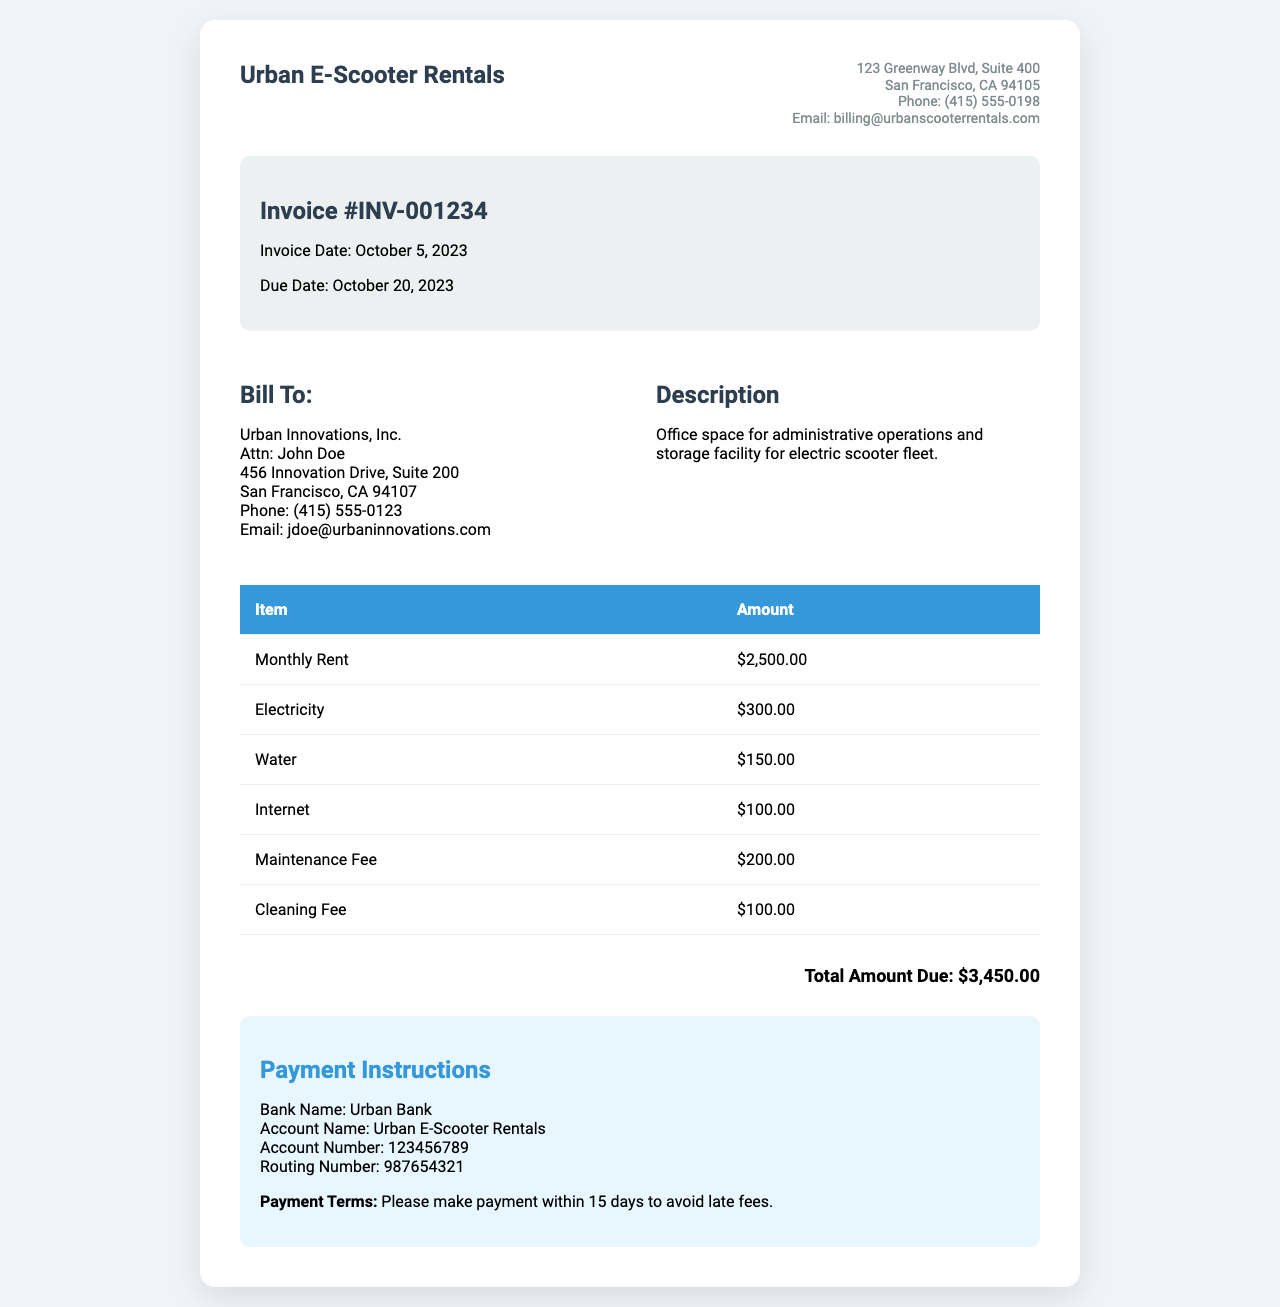What is the invoice number? The invoice number is specified in the document for reference purposes, shown as INV-001234.
Answer: INV-001234 What is the total amount due? The total amount due is calculated at the bottom of the invoice after listing all charges, which total $3,450.00.
Answer: $3,450.00 Who is the billing recipient? The billing recipient's name is provided in the "Bill To" section, which identifies Urban Innovations, Inc. as the company being billed.
Answer: Urban Innovations, Inc What is included in the maintenance fee? The invoice lists various charges, but does not specify the detail of the maintenance fee itself; it is simply presented as an item in the table.
Answer: $200.00 When is the payment due date? The due date for payment is listed in the invoice details, indicating that it is October 20, 2023.
Answer: October 20, 2023 How much is the cleaning fee? The cleaning fee is listed as a separate item within the table of charges, which states it is $100.00.
Answer: $100.00 What is the electricity charge? The electricity charge is specifically outlined in the itemized list of charges provided in the invoice.
Answer: $300.00 What are the payment instructions? The payment instructions detail how to pay, including bank account details, and are provided in a dedicated section at the end of the invoice.
Answer: Bank Name: Urban Bank What is the phone number of the billing recipient? The phone number for the billing recipient is provided alongside their address and contact information, which is (415) 555-0123.
Answer: (415) 555-0123 What date was the invoice issued? The invoice date is clearly mentioned in the document, marking when it was generated.
Answer: October 5, 2023 